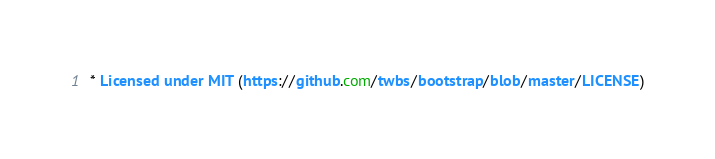Convert code to text. <code><loc_0><loc_0><loc_500><loc_500><_CSS_> * Licensed under MIT (https://github.com/twbs/bootstrap/blob/master/LICENSE)</code> 